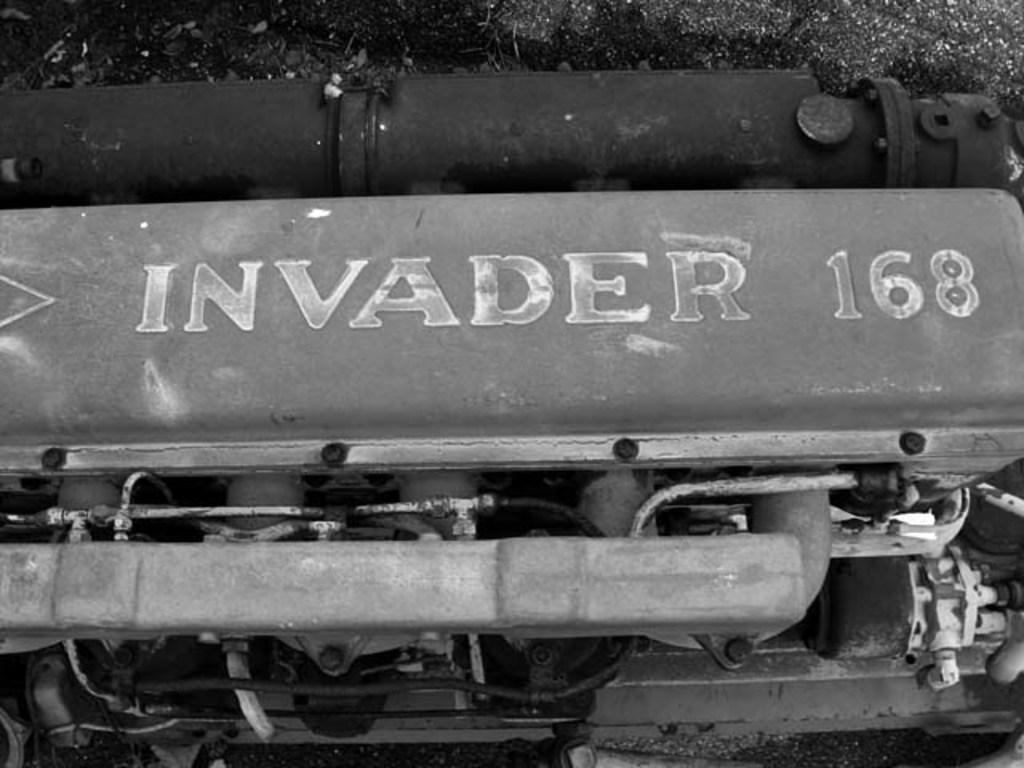<image>
Provide a brief description of the given image. an invader logo on the side of an item 